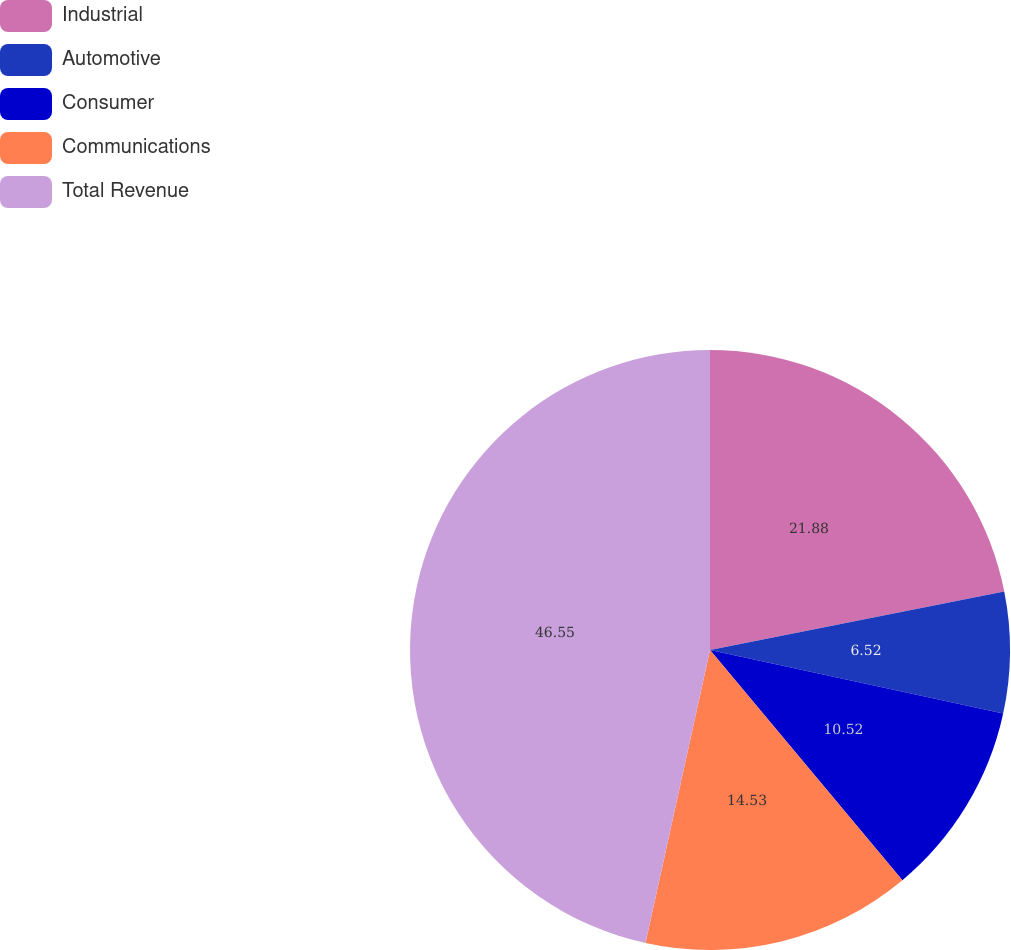<chart> <loc_0><loc_0><loc_500><loc_500><pie_chart><fcel>Industrial<fcel>Automotive<fcel>Consumer<fcel>Communications<fcel>Total Revenue<nl><fcel>21.88%<fcel>6.52%<fcel>10.52%<fcel>14.53%<fcel>46.55%<nl></chart> 